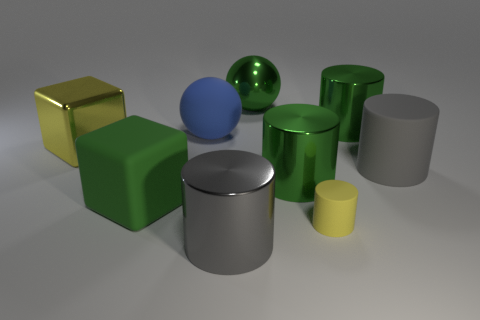There is a large yellow object that is the same material as the big green ball; what is its shape?
Offer a very short reply. Cube. Do the blue matte thing and the green metallic object in front of the big yellow block have the same shape?
Your response must be concise. No. What is the material of the big block that is behind the gray cylinder behind the small matte cylinder?
Offer a terse response. Metal. How many other things are there of the same shape as the tiny yellow matte thing?
Offer a very short reply. 4. There is a green thing that is right of the tiny yellow cylinder; is its shape the same as the yellow object that is to the left of the big blue matte thing?
Your answer should be compact. No. Is there anything else that has the same material as the blue thing?
Provide a short and direct response. Yes. What is the big green cube made of?
Ensure brevity in your answer.  Rubber. What is the gray cylinder on the right side of the tiny yellow rubber thing made of?
Keep it short and to the point. Rubber. Is there anything else that has the same color as the small rubber cylinder?
Make the answer very short. Yes. There is a green object that is the same material as the blue thing; what size is it?
Your answer should be very brief. Large. 